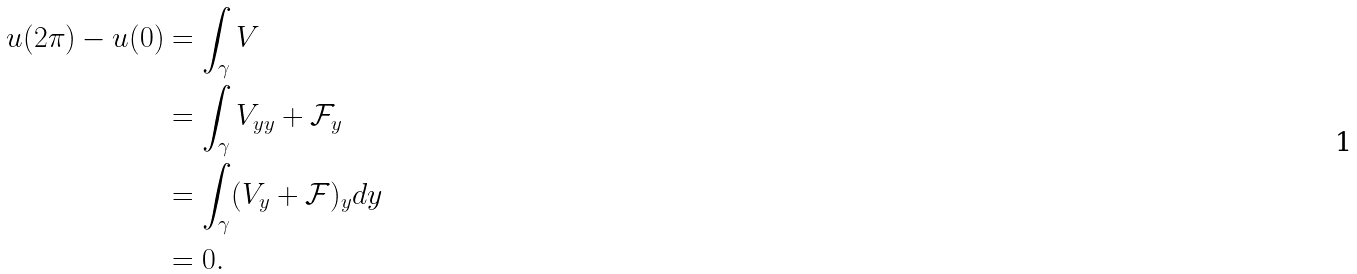<formula> <loc_0><loc_0><loc_500><loc_500>u ( 2 \pi ) - u ( 0 ) & = \int _ { \gamma } V \\ & = \int _ { \gamma } V _ { y y } + \mathcal { F } _ { y } \\ & = \int _ { \gamma } ( V _ { y } + \mathcal { F } ) _ { y } d y \\ & = 0 .</formula> 